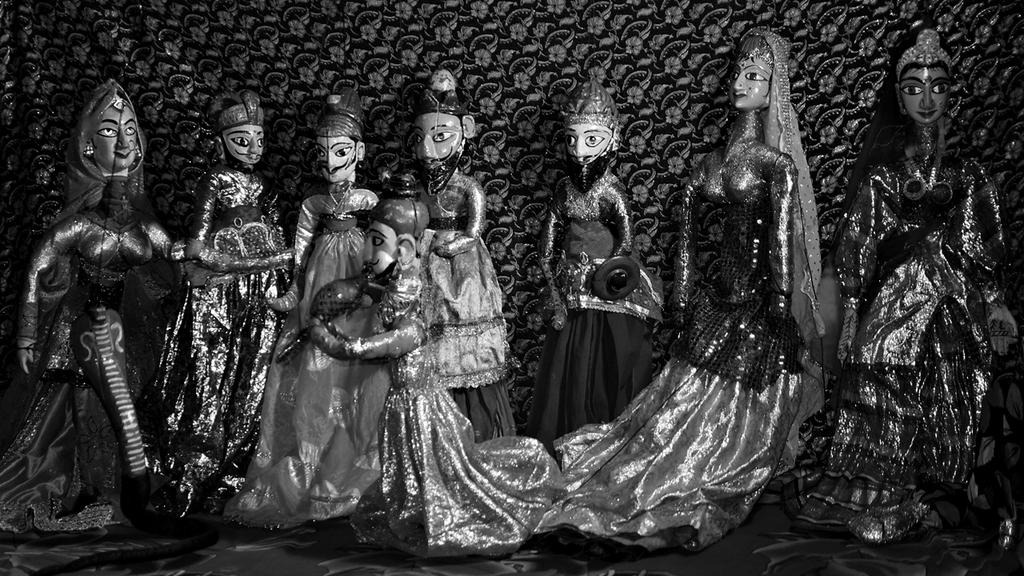What is located in the center of the image? There are dolls in the center of the image. What part of the room can be seen at the bottom of the image? The floor is visible at the bottom of the image. What part of the room can be seen at the top of the image? The wall is visible at the top of the image. What type of actor is performing in the meeting in the image? There is no actor or meeting present in the image; it features dolls in the center of the image. 